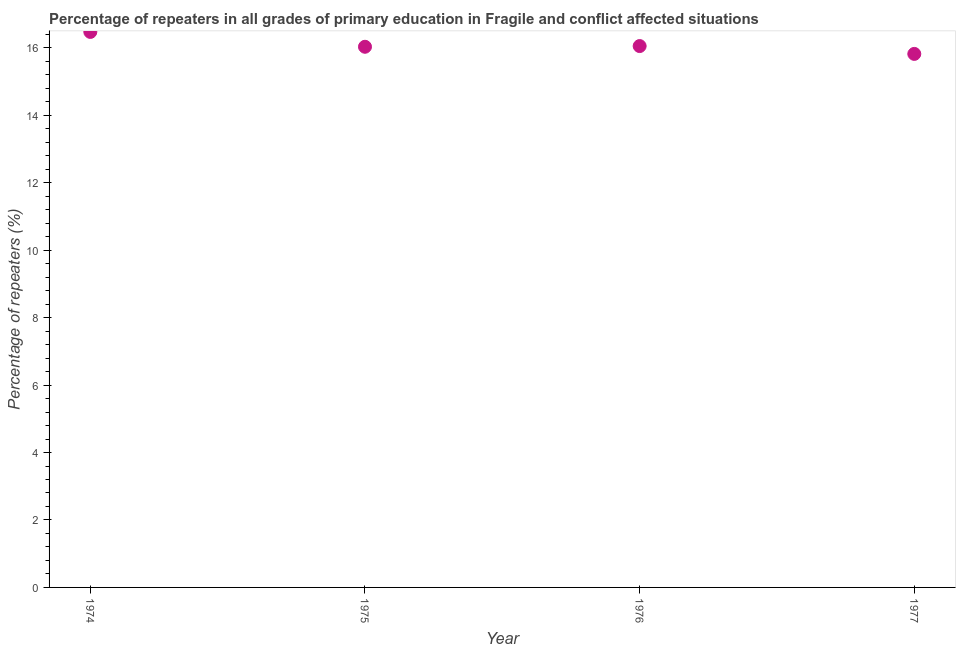What is the percentage of repeaters in primary education in 1976?
Your response must be concise. 16.05. Across all years, what is the maximum percentage of repeaters in primary education?
Offer a very short reply. 16.47. Across all years, what is the minimum percentage of repeaters in primary education?
Provide a succinct answer. 15.82. In which year was the percentage of repeaters in primary education maximum?
Keep it short and to the point. 1974. What is the sum of the percentage of repeaters in primary education?
Provide a short and direct response. 64.38. What is the difference between the percentage of repeaters in primary education in 1975 and 1977?
Your response must be concise. 0.21. What is the average percentage of repeaters in primary education per year?
Offer a very short reply. 16.09. What is the median percentage of repeaters in primary education?
Keep it short and to the point. 16.04. In how many years, is the percentage of repeaters in primary education greater than 6 %?
Ensure brevity in your answer.  4. Do a majority of the years between 1975 and 1977 (inclusive) have percentage of repeaters in primary education greater than 4.4 %?
Offer a very short reply. Yes. What is the ratio of the percentage of repeaters in primary education in 1974 to that in 1975?
Keep it short and to the point. 1.03. Is the percentage of repeaters in primary education in 1974 less than that in 1975?
Make the answer very short. No. What is the difference between the highest and the second highest percentage of repeaters in primary education?
Your response must be concise. 0.42. What is the difference between the highest and the lowest percentage of repeaters in primary education?
Offer a very short reply. 0.65. Does the percentage of repeaters in primary education monotonically increase over the years?
Give a very brief answer. No. How many dotlines are there?
Your answer should be compact. 1. How many years are there in the graph?
Your response must be concise. 4. Are the values on the major ticks of Y-axis written in scientific E-notation?
Provide a succinct answer. No. Does the graph contain any zero values?
Offer a terse response. No. Does the graph contain grids?
Make the answer very short. No. What is the title of the graph?
Your response must be concise. Percentage of repeaters in all grades of primary education in Fragile and conflict affected situations. What is the label or title of the X-axis?
Provide a short and direct response. Year. What is the label or title of the Y-axis?
Offer a terse response. Percentage of repeaters (%). What is the Percentage of repeaters (%) in 1974?
Your answer should be compact. 16.47. What is the Percentage of repeaters (%) in 1975?
Keep it short and to the point. 16.03. What is the Percentage of repeaters (%) in 1976?
Make the answer very short. 16.05. What is the Percentage of repeaters (%) in 1977?
Provide a succinct answer. 15.82. What is the difference between the Percentage of repeaters (%) in 1974 and 1975?
Your answer should be compact. 0.44. What is the difference between the Percentage of repeaters (%) in 1974 and 1976?
Keep it short and to the point. 0.42. What is the difference between the Percentage of repeaters (%) in 1974 and 1977?
Ensure brevity in your answer.  0.65. What is the difference between the Percentage of repeaters (%) in 1975 and 1976?
Keep it short and to the point. -0.02. What is the difference between the Percentage of repeaters (%) in 1975 and 1977?
Your answer should be very brief. 0.21. What is the difference between the Percentage of repeaters (%) in 1976 and 1977?
Give a very brief answer. 0.23. What is the ratio of the Percentage of repeaters (%) in 1974 to that in 1975?
Keep it short and to the point. 1.03. What is the ratio of the Percentage of repeaters (%) in 1974 to that in 1977?
Your answer should be compact. 1.04. What is the ratio of the Percentage of repeaters (%) in 1975 to that in 1977?
Ensure brevity in your answer.  1.01. What is the ratio of the Percentage of repeaters (%) in 1976 to that in 1977?
Offer a terse response. 1.01. 